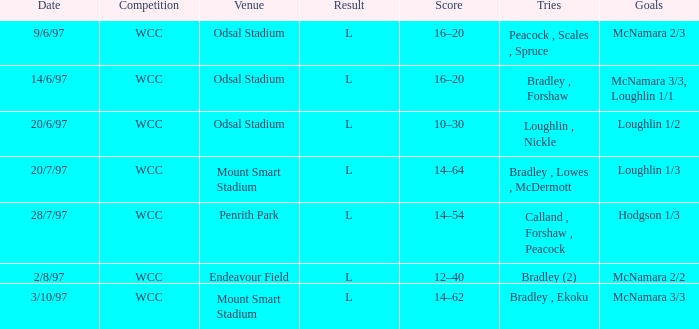What was the score on 20/6/97? 10–30. 